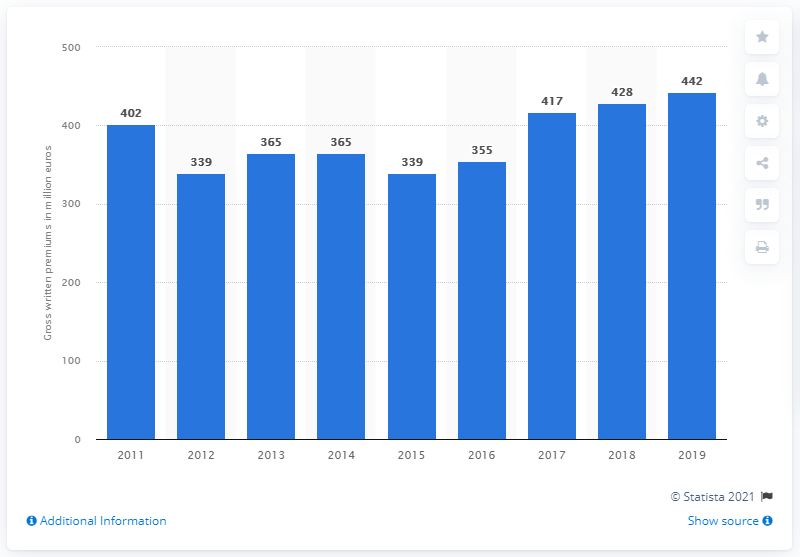Draw attention to some important aspects in this diagram. The highest value of life insurance premiums in Romania in 2019 was 442 million euros. In the years 2012 to 2015, life insurance companies collected a total of 339 million dollars in premiums. 